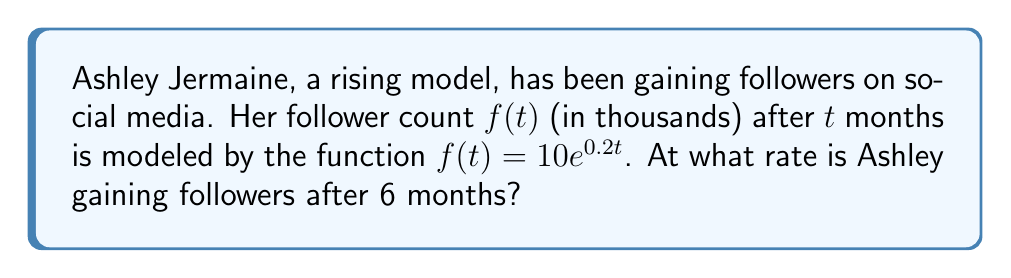Can you answer this question? To find the rate at which Ashley is gaining followers after 6 months, we need to calculate the derivative of the follower function $f(t)$ and evaluate it at $t=6$. Here's the step-by-step process:

1) The given function is $f(t) = 10e^{0.2t}$

2) To find the rate of change, we need to differentiate $f(t)$ with respect to $t$:
   $$\frac{d}{dt}f(t) = 10 \cdot \frac{d}{dt}(e^{0.2t})$$
   $$f'(t) = 10 \cdot 0.2e^{0.2t}$$
   $$f'(t) = 2e^{0.2t}$$

3) This derivative $f'(t)$ represents the instantaneous rate of change of followers at any time $t$.

4) To find the rate after 6 months, we evaluate $f'(t)$ at $t=6$:
   $$f'(6) = 2e^{0.2(6)}$$
   $$f'(6) = 2e^{1.2}$$
   $$f'(6) \approx 6.64$$

5) Since $f(t)$ is in thousands of followers, $f'(t)$ is in thousands of followers per month.

Therefore, after 6 months, Ashley is gaining followers at a rate of approximately 6.64 thousand followers per month.
Answer: 6.64 thousand followers per month 